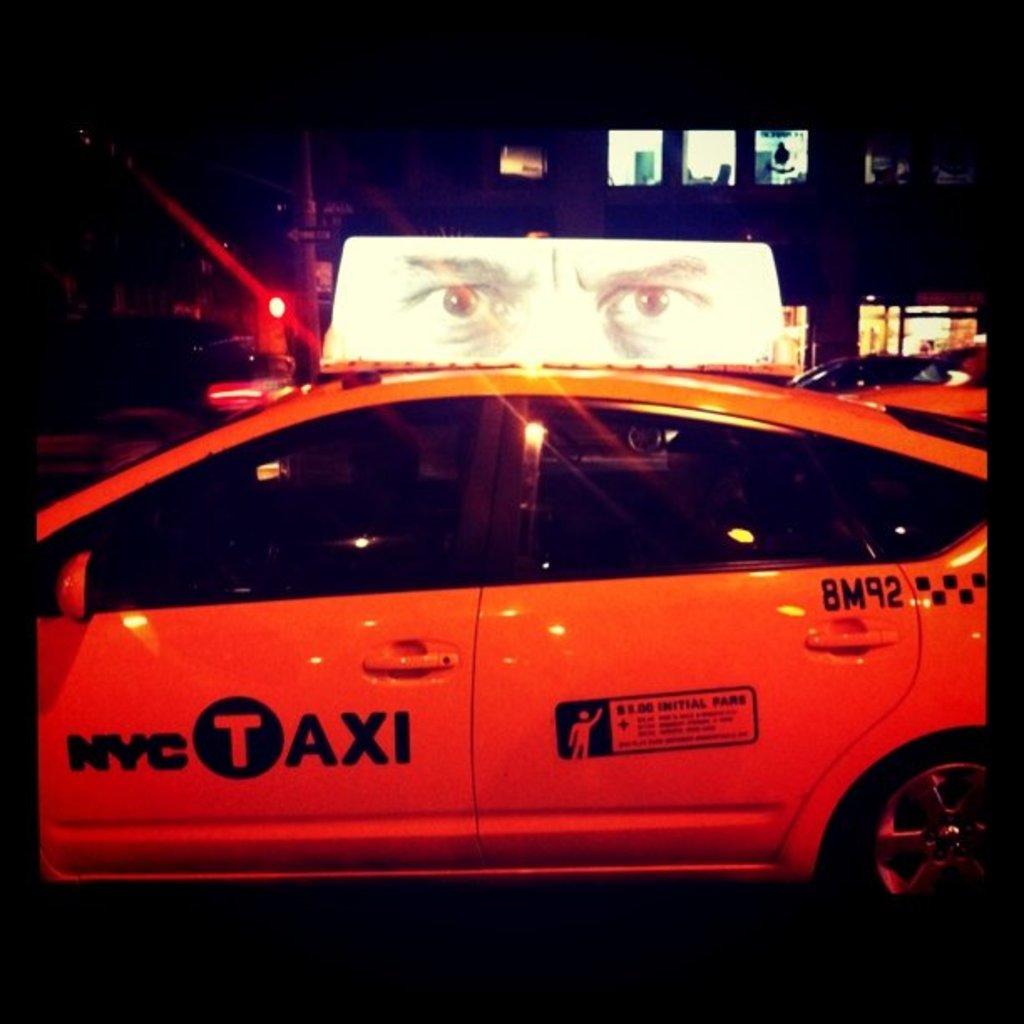What city is this taxi in?
Your answer should be compact. Nyc. 